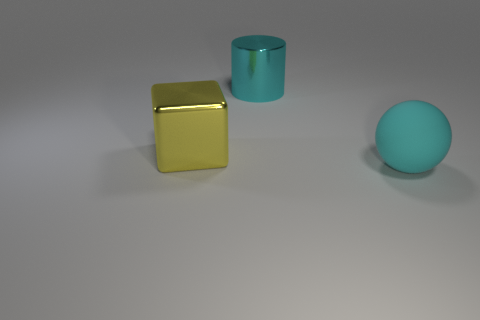There is a large thing that is to the right of the metal cylinder; is its color the same as the big metallic object behind the big yellow metallic cube?
Keep it short and to the point. Yes. There is a metal block that is in front of the cyan thing that is behind the cyan thing in front of the yellow metallic block; what is its size?
Give a very brief answer. Large. Are there more large yellow metallic things to the right of the big cylinder than big green cylinders?
Ensure brevity in your answer.  No. There is a big yellow thing; is it the same shape as the cyan object that is on the left side of the cyan matte sphere?
Your response must be concise. No. Is there anything else that is the same size as the metallic block?
Keep it short and to the point. Yes. Is the number of green spheres greater than the number of large cubes?
Ensure brevity in your answer.  No. Do the rubber thing and the big yellow thing have the same shape?
Offer a very short reply. No. What is the material of the large thing in front of the large metallic object that is to the left of the big cyan metal thing?
Your answer should be compact. Rubber. What is the material of the large ball that is the same color as the shiny cylinder?
Give a very brief answer. Rubber. Is the yellow object the same size as the metallic cylinder?
Your response must be concise. Yes. 